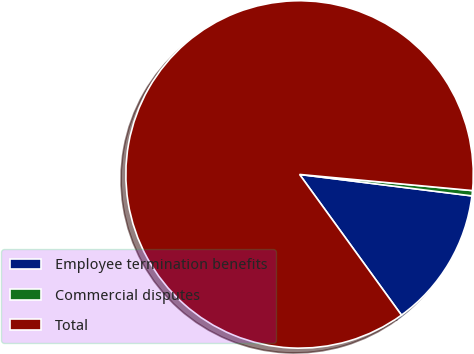<chart> <loc_0><loc_0><loc_500><loc_500><pie_chart><fcel>Employee termination benefits<fcel>Commercial disputes<fcel>Total<nl><fcel>13.05%<fcel>0.49%<fcel>86.45%<nl></chart> 